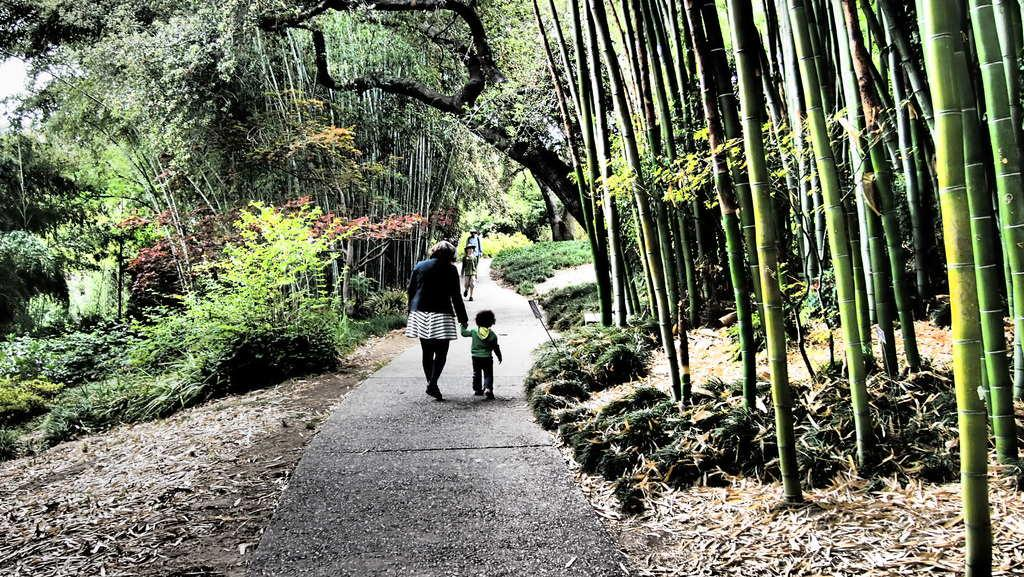What are the people in the image doing? The people in the image are walking in the path in the middle of the picture. What can be seen on either side of the path? There are trees and plants on either side of the path. Can you see your dad in the image? There is no information about your dad in the image, so it cannot be determined if he is present. Are there any cacti visible in the image? The image does not mention any cacti; it only mentions trees and plants. 